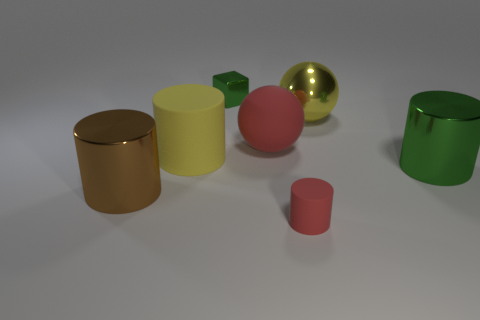Can you tell me what colors are present in the image? Certainly! The image features a variety of colors including gold, green, red, yellow, and two shades of pink. Which object appears to be the smoothest? The golden yellow cylinder seems to have the smoothest surface, reflecting light evenly across its body. 